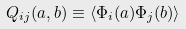Convert formula to latex. <formula><loc_0><loc_0><loc_500><loc_500>Q _ { i j } ( a , b ) \equiv \langle \Phi _ { i } ( a ) \Phi _ { j } ( b ) \rangle</formula> 